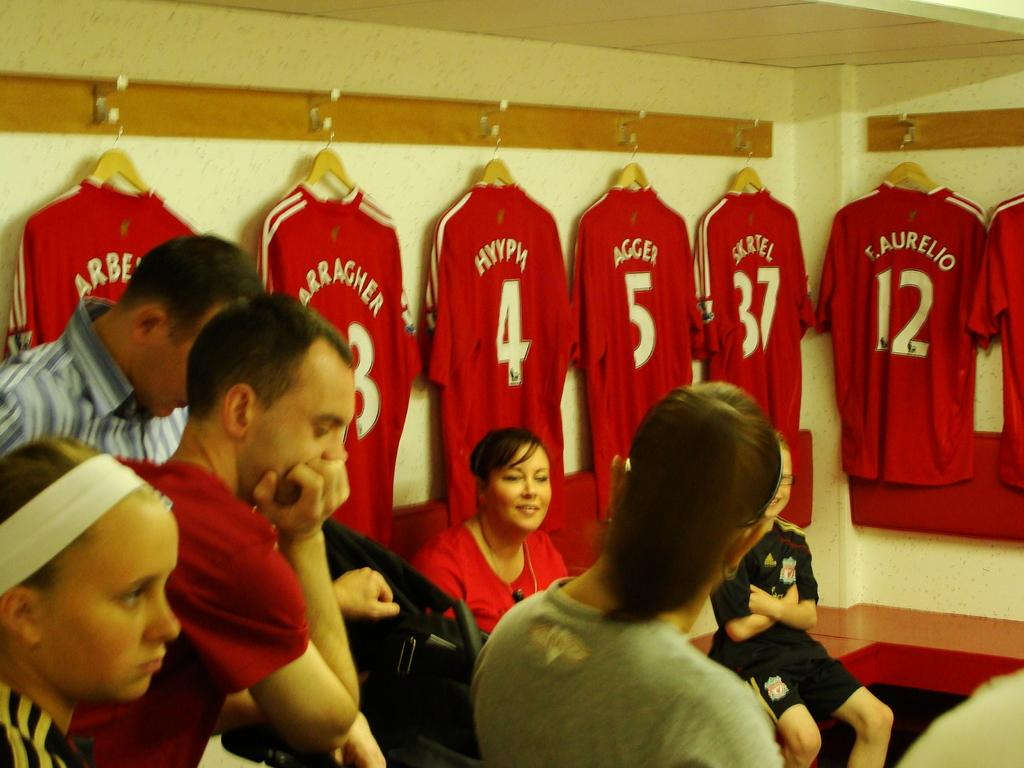<image>
Summarize the visual content of the image. People in front of several hanging jerseys with numbers 3, 4, 5, 37, and 12 